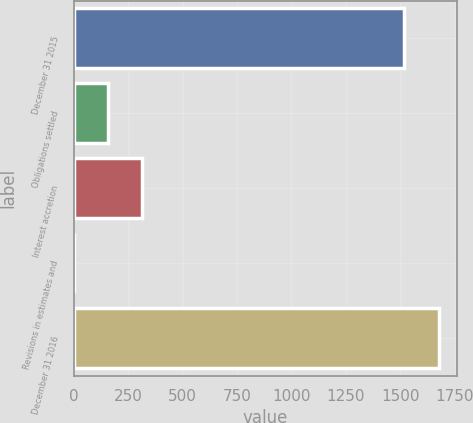<chart> <loc_0><loc_0><loc_500><loc_500><bar_chart><fcel>December 31 2015<fcel>Obligations settled<fcel>Interest accretion<fcel>Revisions in estimates and<fcel>December 31 2016<nl><fcel>1518<fcel>158.5<fcel>316<fcel>1<fcel>1675.5<nl></chart> 